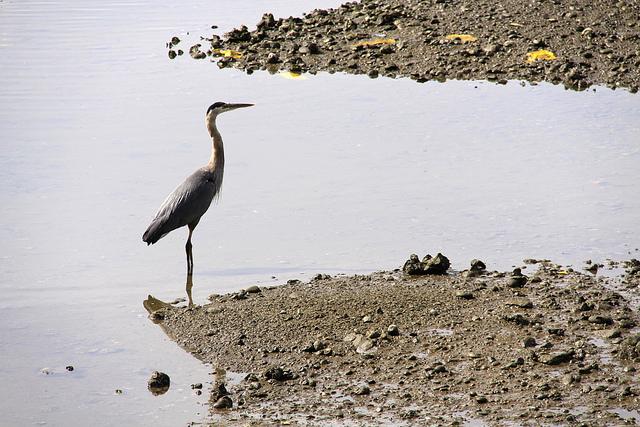Is the bird on the beach?
Give a very brief answer. Yes. What color is it's feathers?
Short answer required. Gray. Where is the bird?
Concise answer only. Shore. What is the bird standing in front of on the left?
Be succinct. Water. Is the bird flying?
Concise answer only. No. What is the bird standing in?
Keep it brief. Sand. Why is one of the birds standing still in field?
Write a very short answer. Resting. What type of birds are these?
Write a very short answer. Crane. What type of bird?
Keep it brief. Crane. Is that a seagull?
Give a very brief answer. No. How many birds are pictured?
Answer briefly. 1. Which is facing the water?
Short answer required. Bird. What substance is the bird walking on?
Write a very short answer. Sand. 